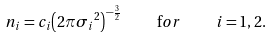<formula> <loc_0><loc_0><loc_500><loc_500>n _ { i } = c _ { i } { \left ( 2 \pi { \sigma _ { i } } ^ { 2 } \right ) } ^ { - \frac { 3 } { 2 } } \quad \mathrm f o r \quad i = 1 , 2 .</formula> 